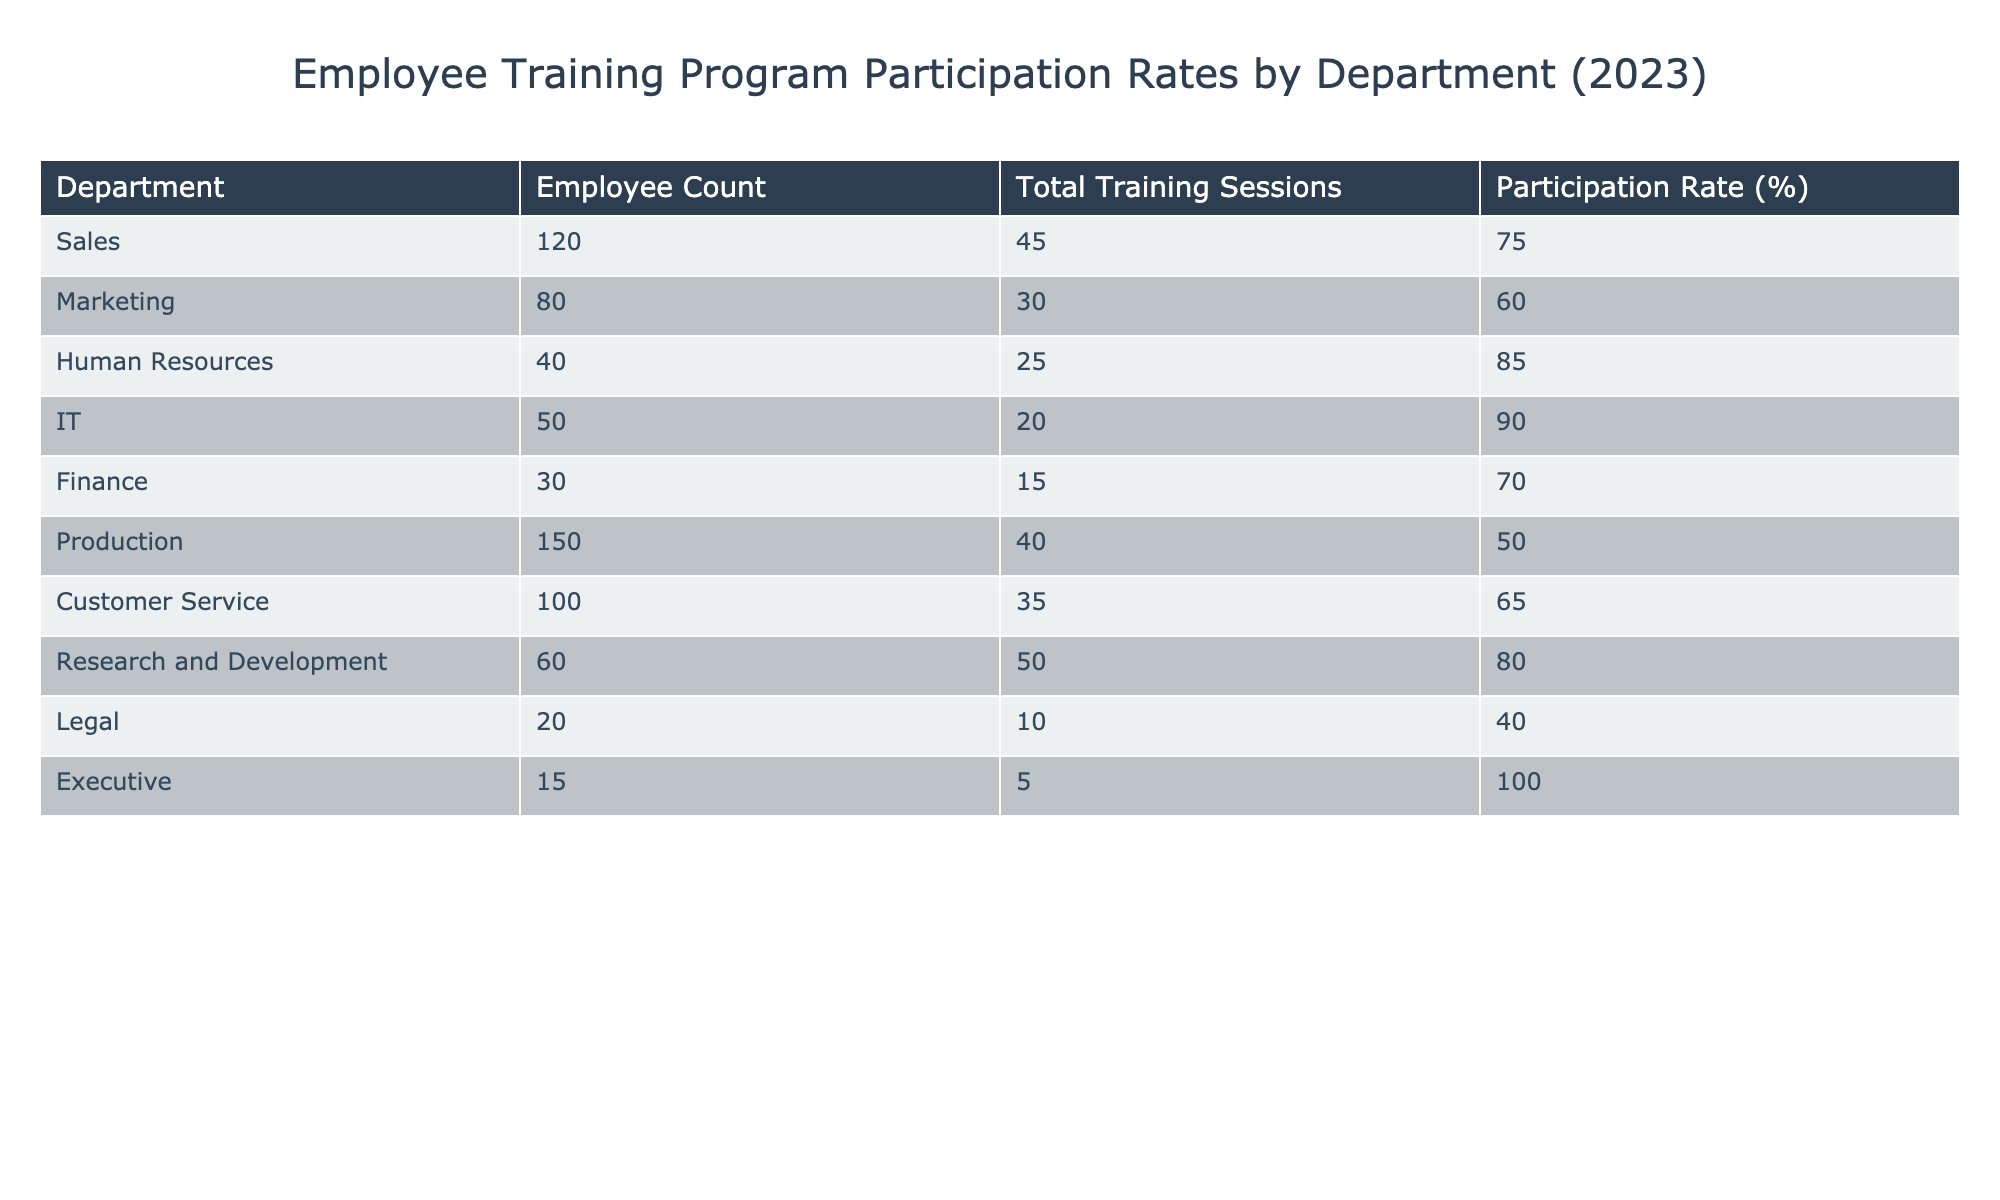What is the participation rate for the IT department? The table shows the participation rate directly in the IT department's row, which is 90%.
Answer: 90% Which department has the highest participation rate? By comparing the participation rates across all departments in the table, IT has the highest participation rate at 90%.
Answer: IT How many total training sessions were conducted in the Marketing department? The table provides the number of total training sessions specifically listed for the Marketing department, which is 30.
Answer: 30 What is the average participation rate for departments with more than 100 employees? Looking at the relevant departments (Sales, Production, and Customer Service) with 120, 150, and 100 employees respectively, their participation rates are 75%, 50%, and 65%. Calculating the average involves summing these rates (75 + 50 + 65 = 190) and dividing by the number of departments (3), resulting in 190/3 = 63.33%.
Answer: 63.33% Is the participation rate for the Legal department greater than 50%? The Legal department has a participation rate of 40%, which is less than 50%.
Answer: No Which departments have a participation rate of 70% or higher? By checking each department's participation rate in the table, the following departments meet or exceed the 70% threshold: Sales (75%), Human Resources (85%), IT (90%), and Research and Development (80%).
Answer: 4 departments What is the total employee count for departments with a participation rate below 60%? Examining the participation rates, the departments with rates below 60% are Production (150 employees) and Legal (20 employees), which together account for 150 + 20 = 170 employees.
Answer: 170 Which department has the lowest employee count and what is its participation rate? The Legal department has the lowest employee count at 20, and its participation rate is 40%.
Answer: 40% How many more training sessions did the Sales department conduct than the Finance department? The Sales department conducted 45 training sessions, while the Finance department conducted 15 sessions. The difference (45 - 15) equals 30 sessions more in Sales.
Answer: 30 